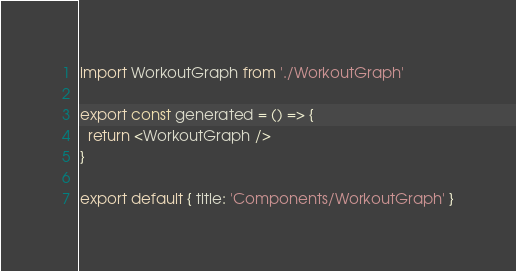Convert code to text. <code><loc_0><loc_0><loc_500><loc_500><_JavaScript_>import WorkoutGraph from './WorkoutGraph'

export const generated = () => {
  return <WorkoutGraph />
}

export default { title: 'Components/WorkoutGraph' }
</code> 